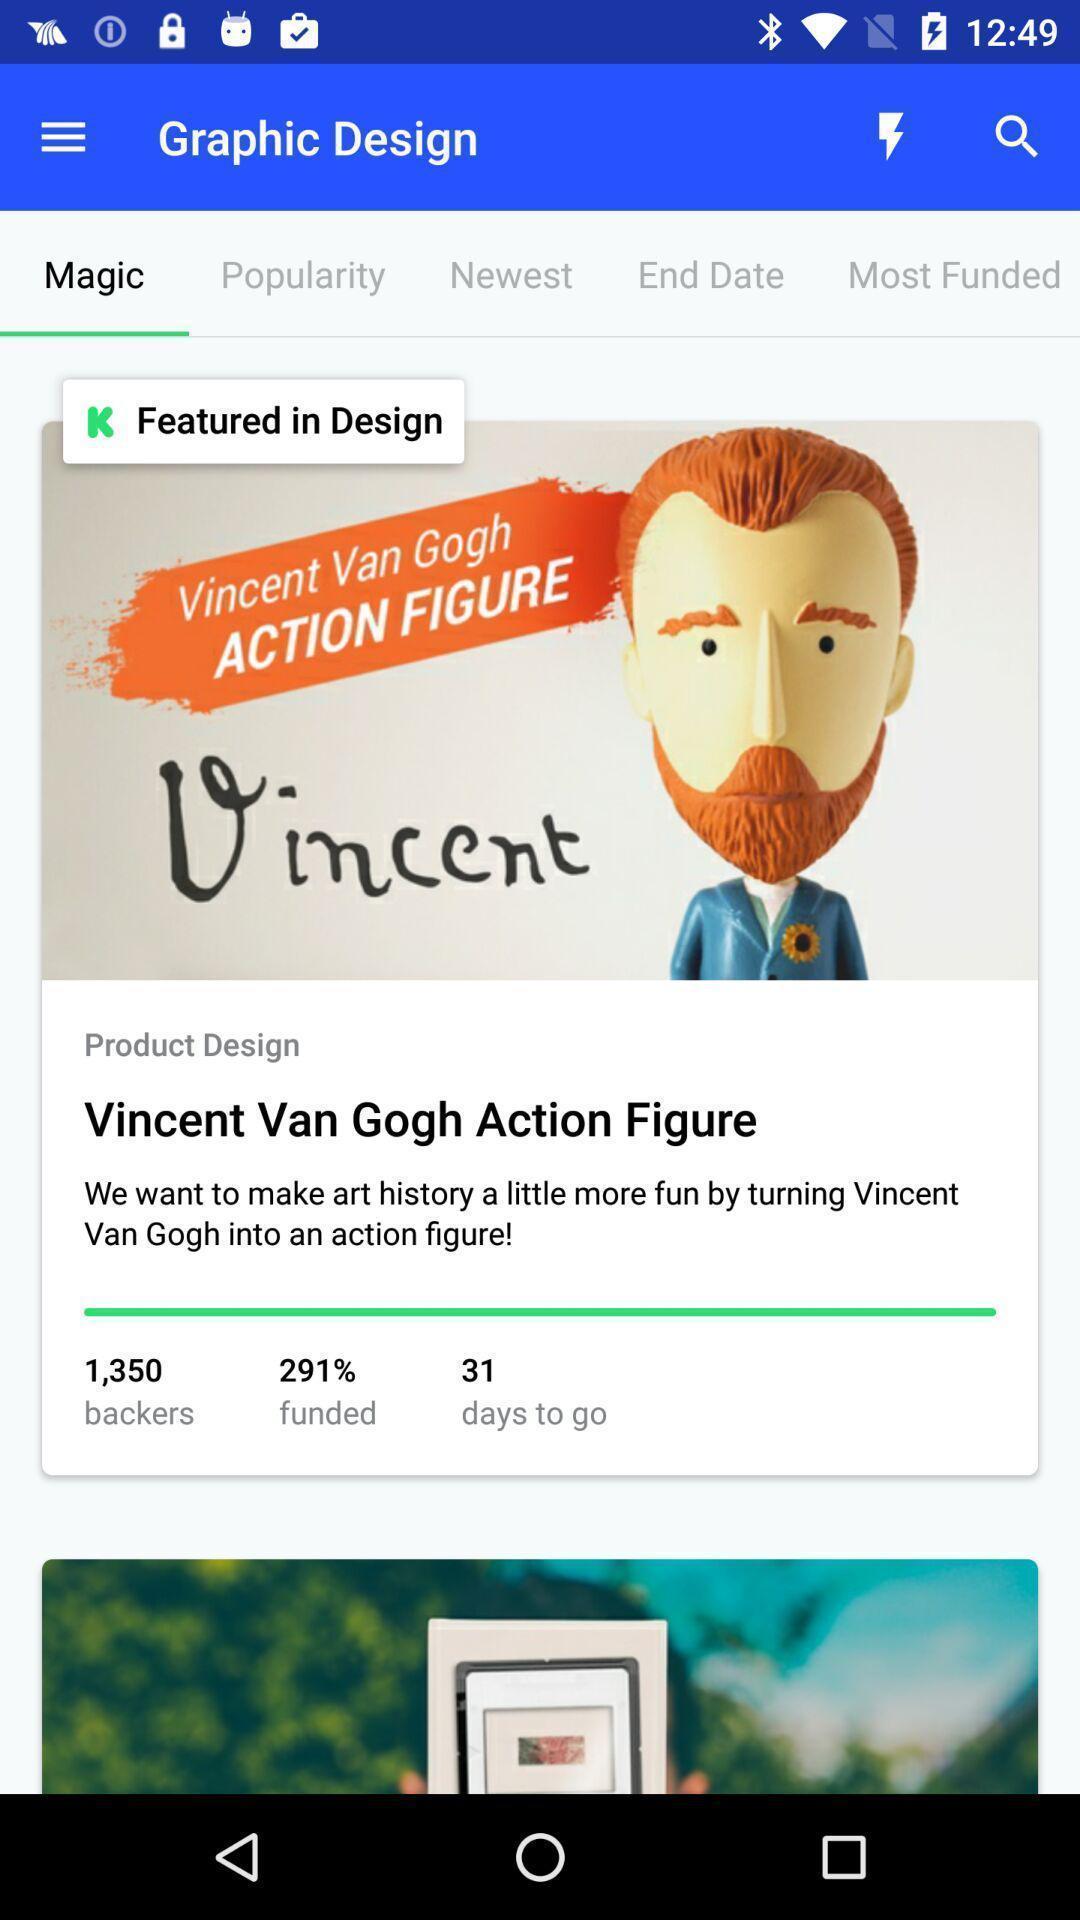Tell me about the visual elements in this screen capture. Screen page of a graphic app. 